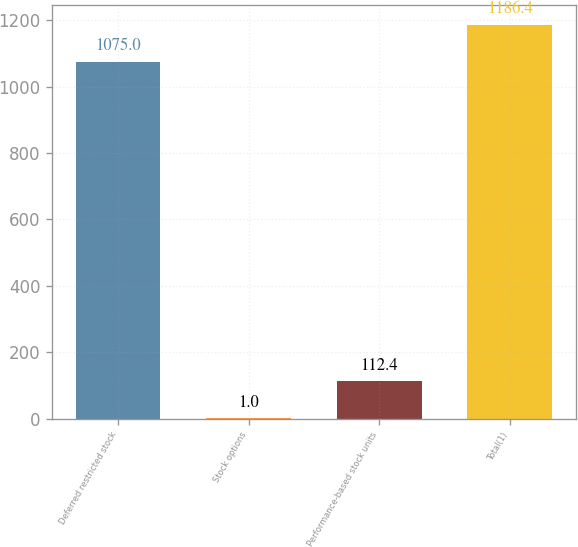<chart> <loc_0><loc_0><loc_500><loc_500><bar_chart><fcel>Deferred restricted stock<fcel>Stock options<fcel>Performance-based stock units<fcel>Total(1)<nl><fcel>1075<fcel>1<fcel>112.4<fcel>1186.4<nl></chart> 